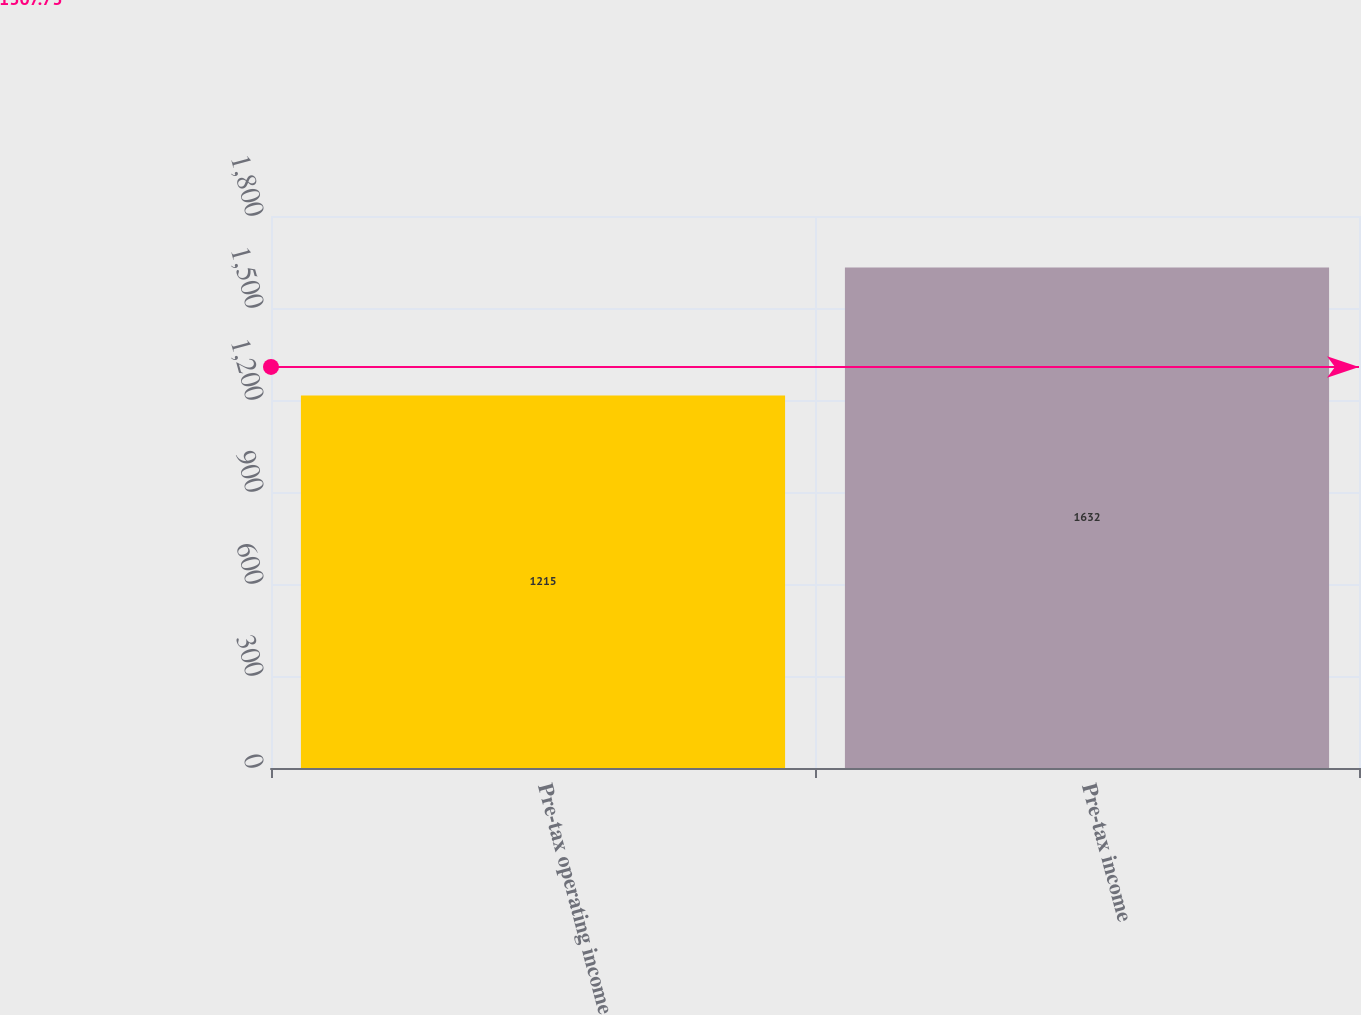<chart> <loc_0><loc_0><loc_500><loc_500><bar_chart><fcel>Pre-tax operating income<fcel>Pre-tax income<nl><fcel>1215<fcel>1632<nl></chart> 